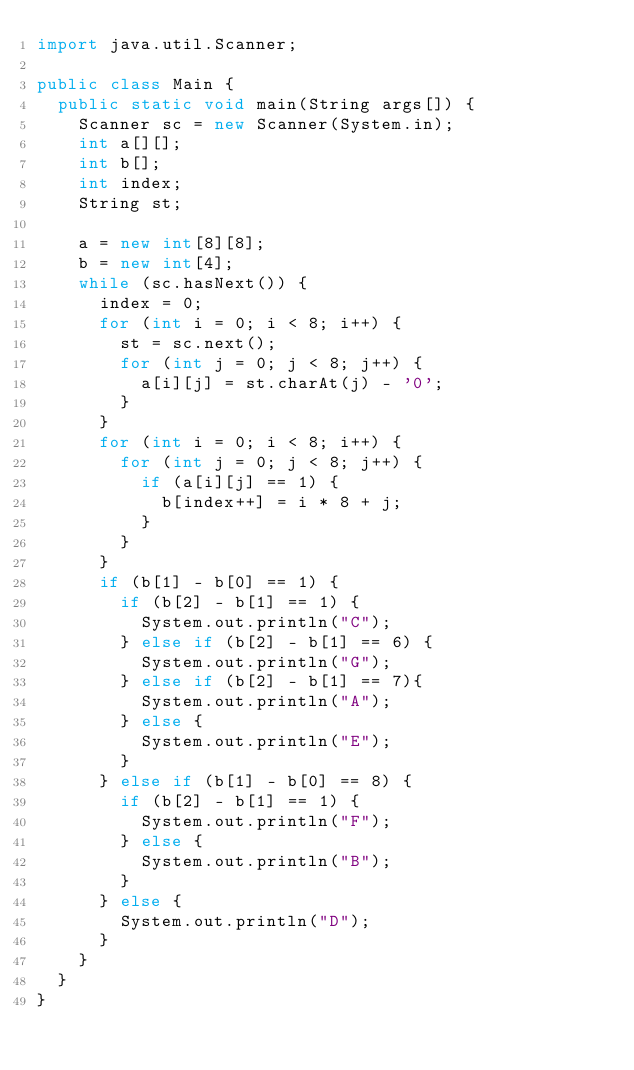Convert code to text. <code><loc_0><loc_0><loc_500><loc_500><_Java_>import java.util.Scanner;

public class Main {
	public static void main(String args[]) {
		Scanner sc = new Scanner(System.in);
		int a[][];
		int b[];
		int index;
		String st;
		
		a = new int[8][8];
		b = new int[4];
		while (sc.hasNext()) {
			index = 0;
			for (int i = 0; i < 8; i++) {
				st = sc.next();
				for (int j = 0; j < 8; j++) {
					a[i][j] = st.charAt(j) - '0';
				}
			}
			for (int i = 0; i < 8; i++) {
				for (int j = 0; j < 8; j++) {
					if (a[i][j] == 1) {
						b[index++] = i * 8 + j;
					}
				}
			}
			if (b[1] - b[0] == 1) {
				if (b[2] - b[1] == 1) {
					System.out.println("C");
				} else if (b[2] - b[1] == 6) {
					System.out.println("G");
				} else if (b[2] - b[1] == 7){
					System.out.println("A");
				} else {
					System.out.println("E");
				}
			} else if (b[1] - b[0] == 8) {
				if (b[2] - b[1] == 1) {
					System.out.println("F");
				} else {
					System.out.println("B");
				}
			} else {
				System.out.println("D");
			}
		}
	}
}</code> 